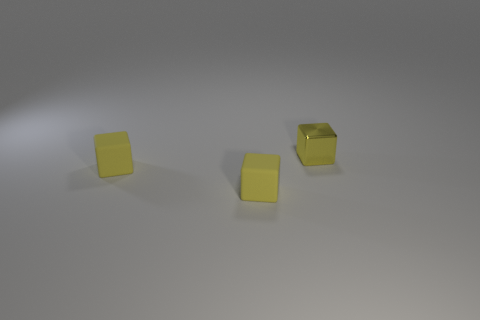What number of other things are the same color as the shiny block?
Make the answer very short. 2. How big is the shiny thing?
Give a very brief answer. Small. How many yellow things are rubber blocks or blocks?
Your answer should be very brief. 3. What number of objects are tiny yellow shiny blocks or small brown matte balls?
Your answer should be very brief. 1. Are there any other small purple metallic objects of the same shape as the metallic object?
Your answer should be compact. No. Are there fewer large red cylinders than shiny cubes?
Keep it short and to the point. Yes. What number of things are tiny metal cubes or objects in front of the small yellow shiny thing?
Your answer should be very brief. 3. What number of small rubber cubes are there?
Offer a terse response. 2. Is there a brown metal cylinder that has the same size as the yellow metal block?
Provide a short and direct response. No. Is the number of yellow cubes on the right side of the small yellow metallic block less than the number of small yellow blocks?
Offer a very short reply. Yes. 